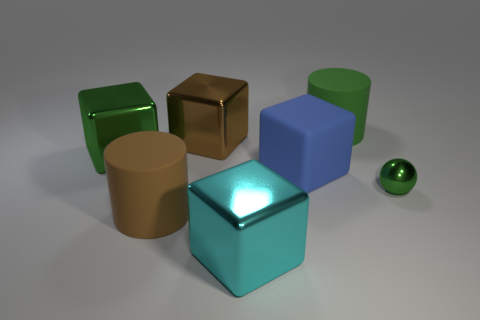Subtract all cyan cubes. How many cubes are left? 3 Subtract all large brown shiny blocks. How many blocks are left? 3 Subtract all red blocks. Subtract all green cylinders. How many blocks are left? 4 Add 3 green blocks. How many objects exist? 10 Subtract all blocks. How many objects are left? 3 Subtract all large rubber cubes. Subtract all small things. How many objects are left? 5 Add 4 brown shiny things. How many brown shiny things are left? 5 Add 1 purple shiny objects. How many purple shiny objects exist? 1 Subtract 0 purple blocks. How many objects are left? 7 